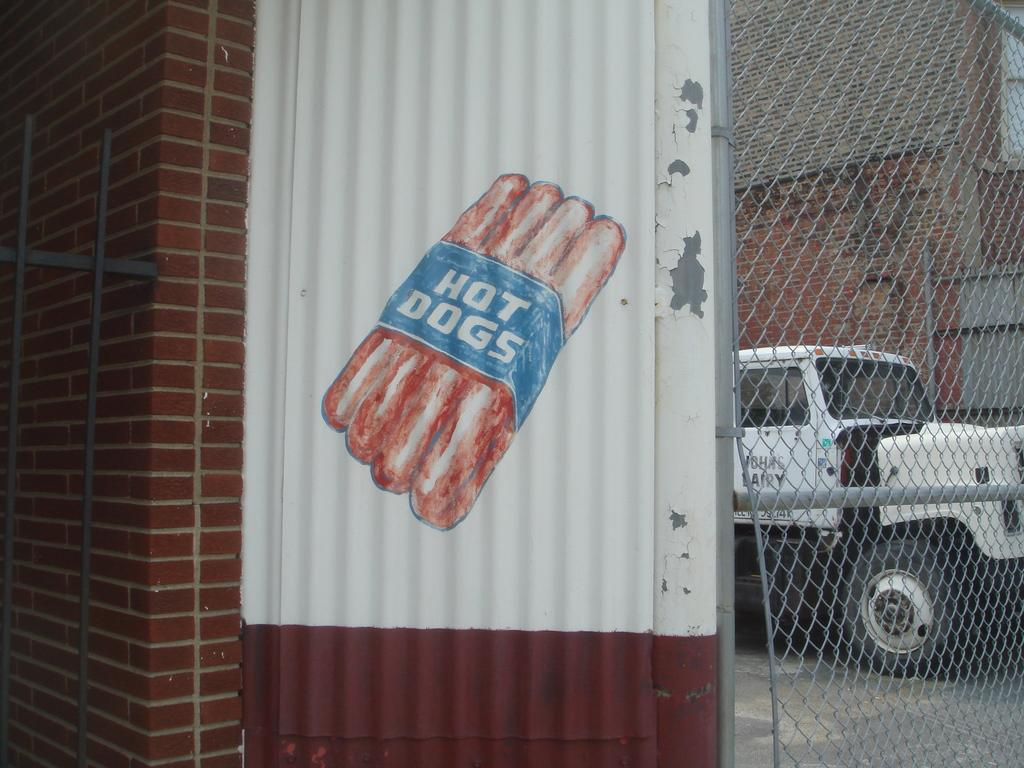What is the main subject of the image? There is a vehicle in the image. What is the setting of the image? The image features a road, a building, and fencing. Can you describe the wall in the image? There is a wall with an image and text in the image. What type of vegetable is being sold at the credit union in the image? There is no credit union or vegetable present in the image. Is there a river visible in the image? No, there is no river visible in the image. 